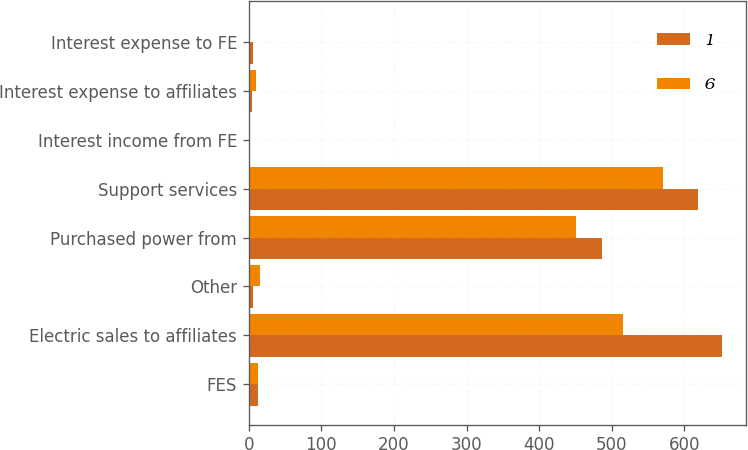Convert chart. <chart><loc_0><loc_0><loc_500><loc_500><stacked_bar_chart><ecel><fcel>FES<fcel>Electric sales to affiliates<fcel>Other<fcel>Purchased power from<fcel>Support services<fcel>Interest income from FE<fcel>Interest expense to affiliates<fcel>Interest expense to FE<nl><fcel>1<fcel>13<fcel>652<fcel>6<fcel>486<fcel>619<fcel>2<fcel>4<fcel>6<nl><fcel>6<fcel>13<fcel>515<fcel>16<fcel>451<fcel>570<fcel>2<fcel>10<fcel>1<nl></chart> 